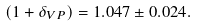Convert formula to latex. <formula><loc_0><loc_0><loc_500><loc_500>( 1 + \delta _ { V P } ) = 1 . 0 4 7 \pm 0 . 0 2 4 .</formula> 